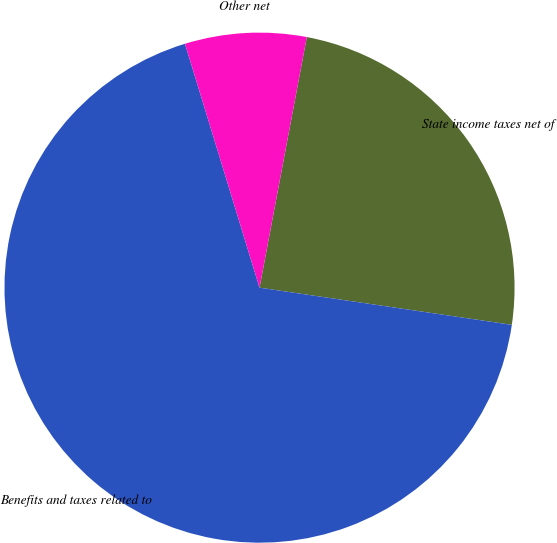Convert chart to OTSL. <chart><loc_0><loc_0><loc_500><loc_500><pie_chart><fcel>State income taxes net of<fcel>Benefits and taxes related to<fcel>Other net<nl><fcel>24.36%<fcel>67.95%<fcel>7.69%<nl></chart> 